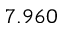Convert formula to latex. <formula><loc_0><loc_0><loc_500><loc_500>7 . 9 6 0</formula> 